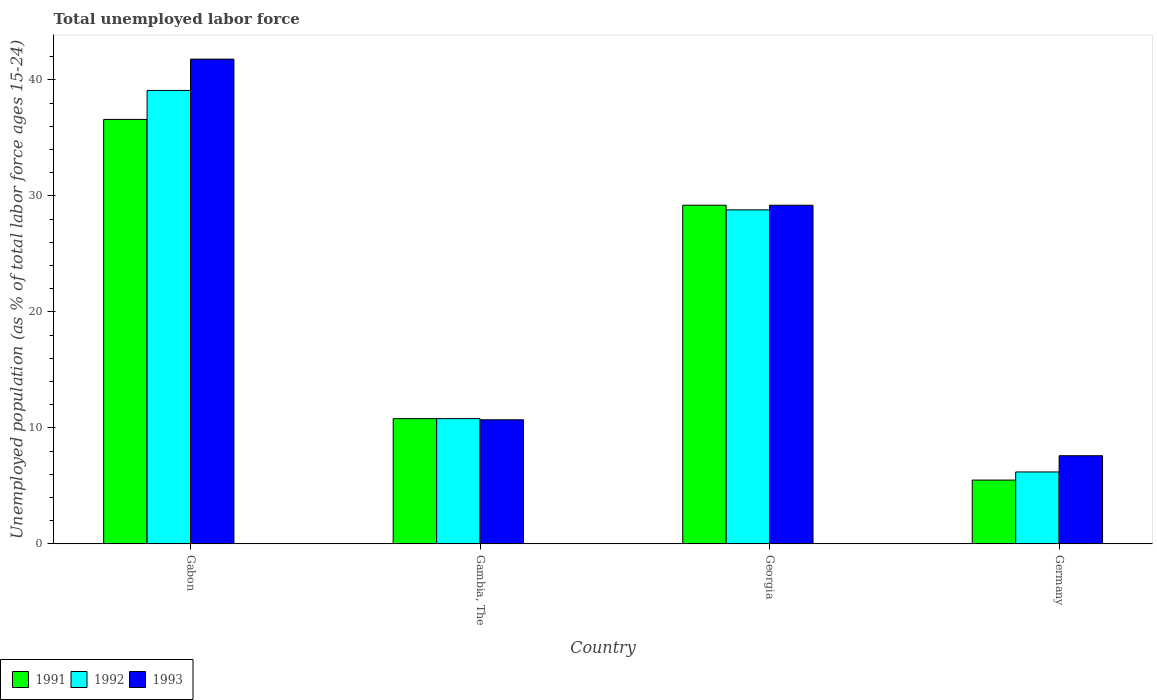How many different coloured bars are there?
Give a very brief answer. 3. How many groups of bars are there?
Your response must be concise. 4. How many bars are there on the 1st tick from the left?
Keep it short and to the point. 3. What is the label of the 3rd group of bars from the left?
Give a very brief answer. Georgia. In how many cases, is the number of bars for a given country not equal to the number of legend labels?
Your answer should be very brief. 0. What is the percentage of unemployed population in in 1992 in Gabon?
Provide a short and direct response. 39.1. Across all countries, what is the maximum percentage of unemployed population in in 1992?
Give a very brief answer. 39.1. Across all countries, what is the minimum percentage of unemployed population in in 1991?
Give a very brief answer. 5.5. In which country was the percentage of unemployed population in in 1992 maximum?
Your answer should be compact. Gabon. What is the total percentage of unemployed population in in 1991 in the graph?
Offer a very short reply. 82.1. What is the difference between the percentage of unemployed population in in 1991 in Gambia, The and that in Germany?
Provide a succinct answer. 5.3. What is the difference between the percentage of unemployed population in in 1991 in Gabon and the percentage of unemployed population in in 1992 in Germany?
Ensure brevity in your answer.  30.4. What is the average percentage of unemployed population in in 1991 per country?
Your answer should be very brief. 20.52. What is the difference between the percentage of unemployed population in of/in 1991 and percentage of unemployed population in of/in 1992 in Germany?
Give a very brief answer. -0.7. What is the ratio of the percentage of unemployed population in in 1993 in Gabon to that in Gambia, The?
Provide a short and direct response. 3.91. Is the percentage of unemployed population in in 1993 in Georgia less than that in Germany?
Your response must be concise. No. What is the difference between the highest and the second highest percentage of unemployed population in in 1992?
Your response must be concise. -18. What is the difference between the highest and the lowest percentage of unemployed population in in 1991?
Give a very brief answer. 31.1. In how many countries, is the percentage of unemployed population in in 1993 greater than the average percentage of unemployed population in in 1993 taken over all countries?
Offer a very short reply. 2. Is the sum of the percentage of unemployed population in in 1992 in Gambia, The and Georgia greater than the maximum percentage of unemployed population in in 1991 across all countries?
Provide a succinct answer. Yes. What does the 3rd bar from the right in Gabon represents?
Give a very brief answer. 1991. How many bars are there?
Make the answer very short. 12. Does the graph contain any zero values?
Your response must be concise. No. Does the graph contain grids?
Provide a succinct answer. No. Where does the legend appear in the graph?
Provide a short and direct response. Bottom left. What is the title of the graph?
Ensure brevity in your answer.  Total unemployed labor force. Does "1964" appear as one of the legend labels in the graph?
Your answer should be compact. No. What is the label or title of the X-axis?
Provide a succinct answer. Country. What is the label or title of the Y-axis?
Your answer should be compact. Unemployed population (as % of total labor force ages 15-24). What is the Unemployed population (as % of total labor force ages 15-24) in 1991 in Gabon?
Make the answer very short. 36.6. What is the Unemployed population (as % of total labor force ages 15-24) of 1992 in Gabon?
Your response must be concise. 39.1. What is the Unemployed population (as % of total labor force ages 15-24) in 1993 in Gabon?
Ensure brevity in your answer.  41.8. What is the Unemployed population (as % of total labor force ages 15-24) in 1991 in Gambia, The?
Your answer should be compact. 10.8. What is the Unemployed population (as % of total labor force ages 15-24) of 1992 in Gambia, The?
Provide a short and direct response. 10.8. What is the Unemployed population (as % of total labor force ages 15-24) in 1993 in Gambia, The?
Offer a terse response. 10.7. What is the Unemployed population (as % of total labor force ages 15-24) of 1991 in Georgia?
Your answer should be very brief. 29.2. What is the Unemployed population (as % of total labor force ages 15-24) in 1992 in Georgia?
Provide a succinct answer. 28.8. What is the Unemployed population (as % of total labor force ages 15-24) in 1993 in Georgia?
Make the answer very short. 29.2. What is the Unemployed population (as % of total labor force ages 15-24) in 1992 in Germany?
Your response must be concise. 6.2. What is the Unemployed population (as % of total labor force ages 15-24) in 1993 in Germany?
Keep it short and to the point. 7.6. Across all countries, what is the maximum Unemployed population (as % of total labor force ages 15-24) in 1991?
Offer a terse response. 36.6. Across all countries, what is the maximum Unemployed population (as % of total labor force ages 15-24) of 1992?
Offer a terse response. 39.1. Across all countries, what is the maximum Unemployed population (as % of total labor force ages 15-24) in 1993?
Your response must be concise. 41.8. Across all countries, what is the minimum Unemployed population (as % of total labor force ages 15-24) in 1992?
Make the answer very short. 6.2. Across all countries, what is the minimum Unemployed population (as % of total labor force ages 15-24) of 1993?
Make the answer very short. 7.6. What is the total Unemployed population (as % of total labor force ages 15-24) in 1991 in the graph?
Ensure brevity in your answer.  82.1. What is the total Unemployed population (as % of total labor force ages 15-24) in 1992 in the graph?
Keep it short and to the point. 84.9. What is the total Unemployed population (as % of total labor force ages 15-24) in 1993 in the graph?
Provide a succinct answer. 89.3. What is the difference between the Unemployed population (as % of total labor force ages 15-24) of 1991 in Gabon and that in Gambia, The?
Provide a short and direct response. 25.8. What is the difference between the Unemployed population (as % of total labor force ages 15-24) of 1992 in Gabon and that in Gambia, The?
Provide a short and direct response. 28.3. What is the difference between the Unemployed population (as % of total labor force ages 15-24) in 1993 in Gabon and that in Gambia, The?
Offer a very short reply. 31.1. What is the difference between the Unemployed population (as % of total labor force ages 15-24) of 1992 in Gabon and that in Georgia?
Your answer should be compact. 10.3. What is the difference between the Unemployed population (as % of total labor force ages 15-24) of 1993 in Gabon and that in Georgia?
Your answer should be compact. 12.6. What is the difference between the Unemployed population (as % of total labor force ages 15-24) in 1991 in Gabon and that in Germany?
Offer a very short reply. 31.1. What is the difference between the Unemployed population (as % of total labor force ages 15-24) in 1992 in Gabon and that in Germany?
Make the answer very short. 32.9. What is the difference between the Unemployed population (as % of total labor force ages 15-24) of 1993 in Gabon and that in Germany?
Keep it short and to the point. 34.2. What is the difference between the Unemployed population (as % of total labor force ages 15-24) of 1991 in Gambia, The and that in Georgia?
Give a very brief answer. -18.4. What is the difference between the Unemployed population (as % of total labor force ages 15-24) of 1992 in Gambia, The and that in Georgia?
Offer a terse response. -18. What is the difference between the Unemployed population (as % of total labor force ages 15-24) of 1993 in Gambia, The and that in Georgia?
Your answer should be compact. -18.5. What is the difference between the Unemployed population (as % of total labor force ages 15-24) of 1991 in Gambia, The and that in Germany?
Provide a short and direct response. 5.3. What is the difference between the Unemployed population (as % of total labor force ages 15-24) of 1992 in Gambia, The and that in Germany?
Provide a succinct answer. 4.6. What is the difference between the Unemployed population (as % of total labor force ages 15-24) in 1991 in Georgia and that in Germany?
Make the answer very short. 23.7. What is the difference between the Unemployed population (as % of total labor force ages 15-24) in 1992 in Georgia and that in Germany?
Provide a succinct answer. 22.6. What is the difference between the Unemployed population (as % of total labor force ages 15-24) of 1993 in Georgia and that in Germany?
Your response must be concise. 21.6. What is the difference between the Unemployed population (as % of total labor force ages 15-24) of 1991 in Gabon and the Unemployed population (as % of total labor force ages 15-24) of 1992 in Gambia, The?
Your answer should be compact. 25.8. What is the difference between the Unemployed population (as % of total labor force ages 15-24) in 1991 in Gabon and the Unemployed population (as % of total labor force ages 15-24) in 1993 in Gambia, The?
Ensure brevity in your answer.  25.9. What is the difference between the Unemployed population (as % of total labor force ages 15-24) in 1992 in Gabon and the Unemployed population (as % of total labor force ages 15-24) in 1993 in Gambia, The?
Offer a terse response. 28.4. What is the difference between the Unemployed population (as % of total labor force ages 15-24) in 1991 in Gabon and the Unemployed population (as % of total labor force ages 15-24) in 1993 in Georgia?
Give a very brief answer. 7.4. What is the difference between the Unemployed population (as % of total labor force ages 15-24) of 1991 in Gabon and the Unemployed population (as % of total labor force ages 15-24) of 1992 in Germany?
Offer a very short reply. 30.4. What is the difference between the Unemployed population (as % of total labor force ages 15-24) of 1991 in Gabon and the Unemployed population (as % of total labor force ages 15-24) of 1993 in Germany?
Your response must be concise. 29. What is the difference between the Unemployed population (as % of total labor force ages 15-24) of 1992 in Gabon and the Unemployed population (as % of total labor force ages 15-24) of 1993 in Germany?
Your answer should be compact. 31.5. What is the difference between the Unemployed population (as % of total labor force ages 15-24) of 1991 in Gambia, The and the Unemployed population (as % of total labor force ages 15-24) of 1993 in Georgia?
Your answer should be compact. -18.4. What is the difference between the Unemployed population (as % of total labor force ages 15-24) in 1992 in Gambia, The and the Unemployed population (as % of total labor force ages 15-24) in 1993 in Georgia?
Your answer should be compact. -18.4. What is the difference between the Unemployed population (as % of total labor force ages 15-24) in 1991 in Gambia, The and the Unemployed population (as % of total labor force ages 15-24) in 1993 in Germany?
Give a very brief answer. 3.2. What is the difference between the Unemployed population (as % of total labor force ages 15-24) of 1992 in Gambia, The and the Unemployed population (as % of total labor force ages 15-24) of 1993 in Germany?
Provide a succinct answer. 3.2. What is the difference between the Unemployed population (as % of total labor force ages 15-24) of 1991 in Georgia and the Unemployed population (as % of total labor force ages 15-24) of 1993 in Germany?
Keep it short and to the point. 21.6. What is the difference between the Unemployed population (as % of total labor force ages 15-24) in 1992 in Georgia and the Unemployed population (as % of total labor force ages 15-24) in 1993 in Germany?
Your answer should be very brief. 21.2. What is the average Unemployed population (as % of total labor force ages 15-24) in 1991 per country?
Your answer should be very brief. 20.52. What is the average Unemployed population (as % of total labor force ages 15-24) in 1992 per country?
Provide a short and direct response. 21.23. What is the average Unemployed population (as % of total labor force ages 15-24) in 1993 per country?
Your answer should be very brief. 22.32. What is the difference between the Unemployed population (as % of total labor force ages 15-24) in 1991 and Unemployed population (as % of total labor force ages 15-24) in 1992 in Gabon?
Your response must be concise. -2.5. What is the difference between the Unemployed population (as % of total labor force ages 15-24) of 1991 and Unemployed population (as % of total labor force ages 15-24) of 1992 in Gambia, The?
Offer a very short reply. 0. What is the difference between the Unemployed population (as % of total labor force ages 15-24) of 1991 and Unemployed population (as % of total labor force ages 15-24) of 1993 in Gambia, The?
Provide a short and direct response. 0.1. What is the ratio of the Unemployed population (as % of total labor force ages 15-24) in 1991 in Gabon to that in Gambia, The?
Your response must be concise. 3.39. What is the ratio of the Unemployed population (as % of total labor force ages 15-24) of 1992 in Gabon to that in Gambia, The?
Keep it short and to the point. 3.62. What is the ratio of the Unemployed population (as % of total labor force ages 15-24) of 1993 in Gabon to that in Gambia, The?
Offer a very short reply. 3.91. What is the ratio of the Unemployed population (as % of total labor force ages 15-24) in 1991 in Gabon to that in Georgia?
Ensure brevity in your answer.  1.25. What is the ratio of the Unemployed population (as % of total labor force ages 15-24) of 1992 in Gabon to that in Georgia?
Ensure brevity in your answer.  1.36. What is the ratio of the Unemployed population (as % of total labor force ages 15-24) in 1993 in Gabon to that in Georgia?
Provide a short and direct response. 1.43. What is the ratio of the Unemployed population (as % of total labor force ages 15-24) of 1991 in Gabon to that in Germany?
Offer a very short reply. 6.65. What is the ratio of the Unemployed population (as % of total labor force ages 15-24) in 1992 in Gabon to that in Germany?
Your answer should be very brief. 6.31. What is the ratio of the Unemployed population (as % of total labor force ages 15-24) in 1991 in Gambia, The to that in Georgia?
Provide a short and direct response. 0.37. What is the ratio of the Unemployed population (as % of total labor force ages 15-24) in 1993 in Gambia, The to that in Georgia?
Your response must be concise. 0.37. What is the ratio of the Unemployed population (as % of total labor force ages 15-24) of 1991 in Gambia, The to that in Germany?
Make the answer very short. 1.96. What is the ratio of the Unemployed population (as % of total labor force ages 15-24) in 1992 in Gambia, The to that in Germany?
Offer a terse response. 1.74. What is the ratio of the Unemployed population (as % of total labor force ages 15-24) in 1993 in Gambia, The to that in Germany?
Offer a very short reply. 1.41. What is the ratio of the Unemployed population (as % of total labor force ages 15-24) in 1991 in Georgia to that in Germany?
Your answer should be very brief. 5.31. What is the ratio of the Unemployed population (as % of total labor force ages 15-24) of 1992 in Georgia to that in Germany?
Offer a very short reply. 4.65. What is the ratio of the Unemployed population (as % of total labor force ages 15-24) of 1993 in Georgia to that in Germany?
Offer a very short reply. 3.84. What is the difference between the highest and the second highest Unemployed population (as % of total labor force ages 15-24) of 1992?
Keep it short and to the point. 10.3. What is the difference between the highest and the second highest Unemployed population (as % of total labor force ages 15-24) of 1993?
Your answer should be very brief. 12.6. What is the difference between the highest and the lowest Unemployed population (as % of total labor force ages 15-24) of 1991?
Your answer should be compact. 31.1. What is the difference between the highest and the lowest Unemployed population (as % of total labor force ages 15-24) of 1992?
Ensure brevity in your answer.  32.9. What is the difference between the highest and the lowest Unemployed population (as % of total labor force ages 15-24) of 1993?
Provide a short and direct response. 34.2. 